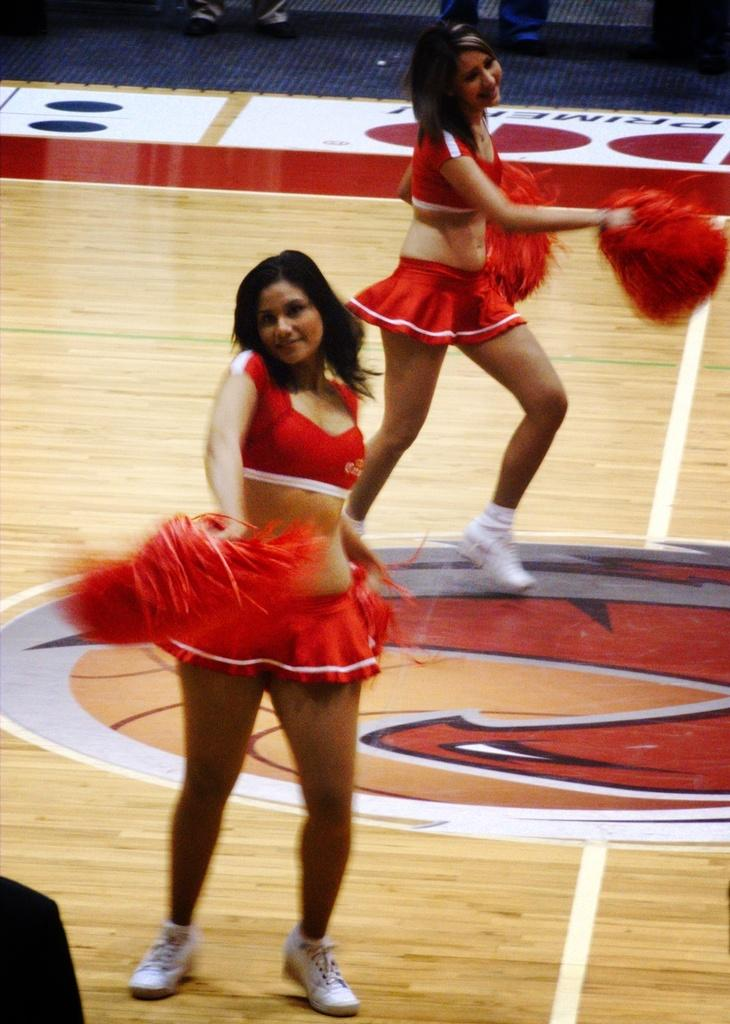How many people are in the image? There are two women in the image. What are the women doing in the image? The women are dancing on the floor. What are the women wearing in the image? The women are wearing red color dresses. What is the color of the floor in the image? The floor is in cream color. What type of trouble is the bucket causing in the image? There is no bucket present in the image, so it cannot cause any trouble. 